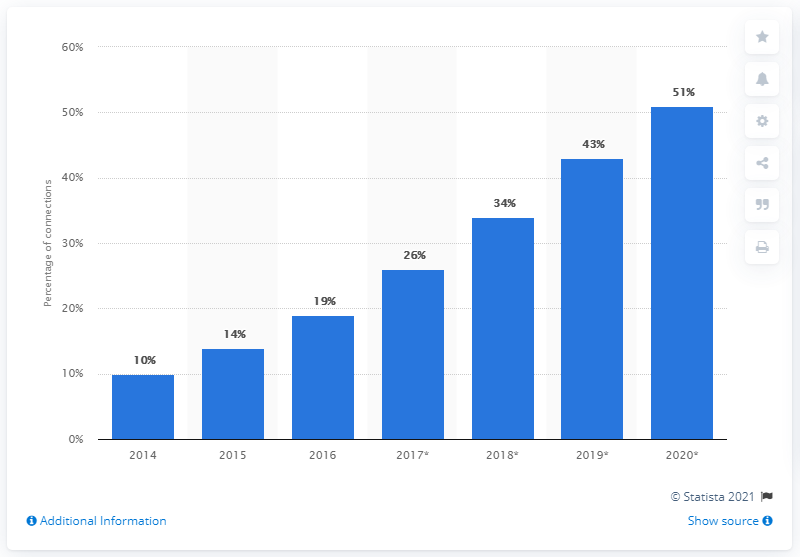Give some essential details in this illustration. Pakistan's smartphone penetration rate was forecasted to reach 51% by the end of 2020. 